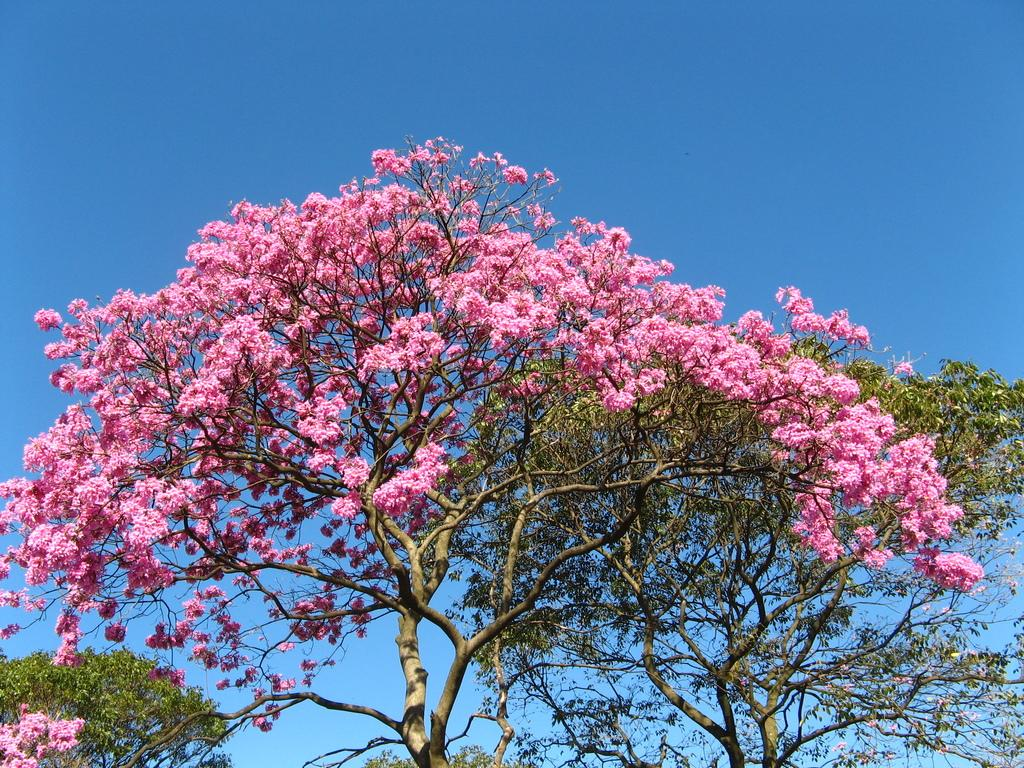What type of vegetation can be seen in the image? There are trees in the image. What other natural elements can be seen in the image? There are flowers in the image. What is visible in the background of the image? The sky is visible in the background of the image. What religion is being practiced in the image? There is no indication of any religious practice in the image; it features trees, flowers, and the sky. What type of trade is being conducted in the image? There is no indication of any trade activity in the image; it features trees, flowers, and the sky. 